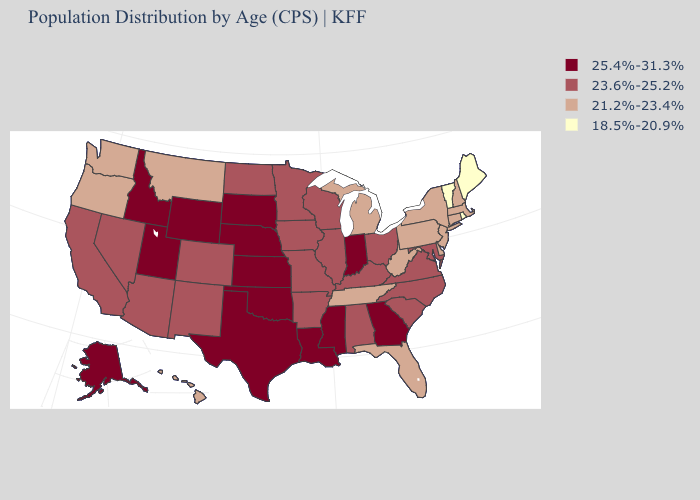Among the states that border Idaho , which have the highest value?
Be succinct. Utah, Wyoming. Does the first symbol in the legend represent the smallest category?
Short answer required. No. Name the states that have a value in the range 18.5%-20.9%?
Be succinct. Maine, Rhode Island, Vermont. Which states have the highest value in the USA?
Quick response, please. Alaska, Georgia, Idaho, Indiana, Kansas, Louisiana, Mississippi, Nebraska, Oklahoma, South Dakota, Texas, Utah, Wyoming. What is the highest value in the USA?
Quick response, please. 25.4%-31.3%. What is the highest value in the USA?
Short answer required. 25.4%-31.3%. Name the states that have a value in the range 21.2%-23.4%?
Concise answer only. Connecticut, Delaware, Florida, Hawaii, Massachusetts, Michigan, Montana, New Hampshire, New Jersey, New York, Oregon, Pennsylvania, Tennessee, Washington, West Virginia. Which states have the highest value in the USA?
Concise answer only. Alaska, Georgia, Idaho, Indiana, Kansas, Louisiana, Mississippi, Nebraska, Oklahoma, South Dakota, Texas, Utah, Wyoming. What is the value of Utah?
Short answer required. 25.4%-31.3%. What is the value of Arizona?
Write a very short answer. 23.6%-25.2%. Name the states that have a value in the range 25.4%-31.3%?
Concise answer only. Alaska, Georgia, Idaho, Indiana, Kansas, Louisiana, Mississippi, Nebraska, Oklahoma, South Dakota, Texas, Utah, Wyoming. Among the states that border North Carolina , does Georgia have the lowest value?
Short answer required. No. Does the first symbol in the legend represent the smallest category?
Be succinct. No. What is the highest value in states that border North Dakota?
Short answer required. 25.4%-31.3%. Name the states that have a value in the range 21.2%-23.4%?
Short answer required. Connecticut, Delaware, Florida, Hawaii, Massachusetts, Michigan, Montana, New Hampshire, New Jersey, New York, Oregon, Pennsylvania, Tennessee, Washington, West Virginia. 